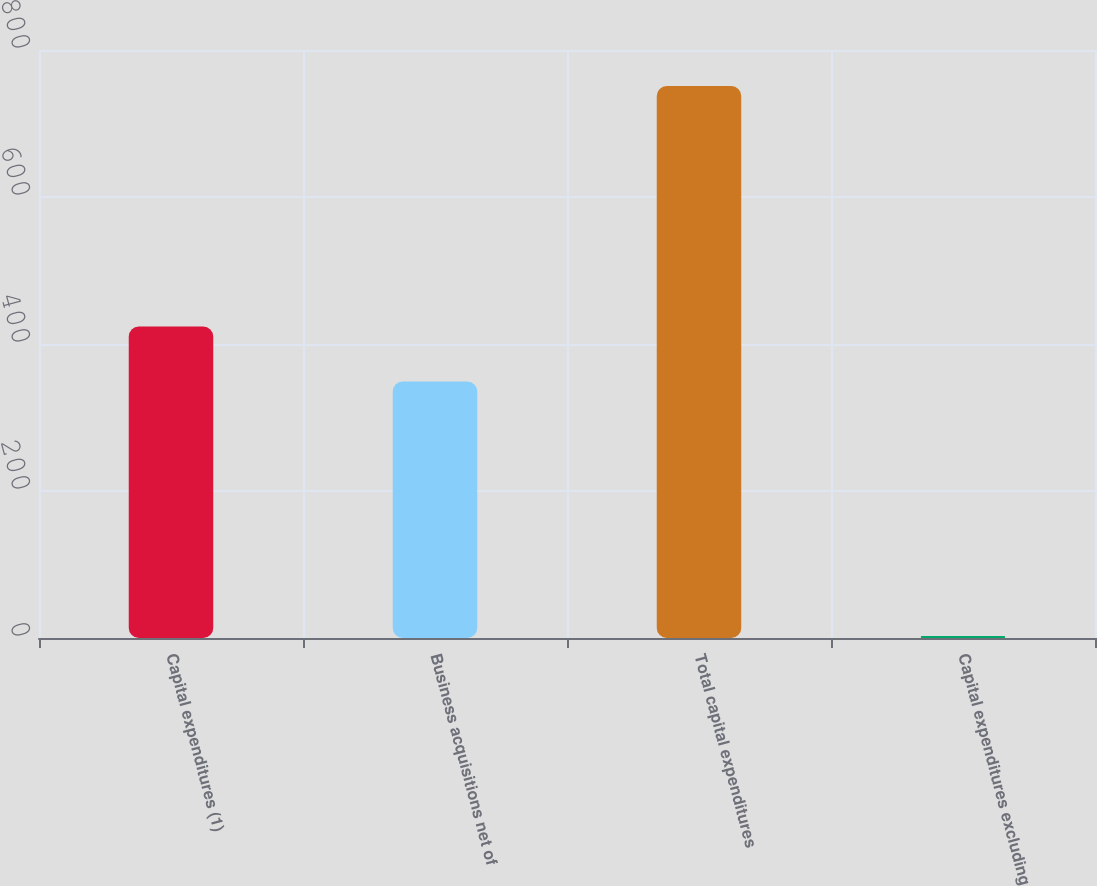<chart> <loc_0><loc_0><loc_500><loc_500><bar_chart><fcel>Capital expenditures (1)<fcel>Business acquisitions net of<fcel>Total capital expenditures<fcel>Capital expenditures excluding<nl><fcel>423.83<fcel>349<fcel>751<fcel>2.7<nl></chart> 